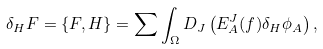Convert formula to latex. <formula><loc_0><loc_0><loc_500><loc_500>\delta _ { H } F = \{ F , H \} = \sum \int _ { \Omega } D _ { J } \left ( E ^ { J } _ { A } ( f ) \delta _ { H } \phi _ { A } \right ) ,</formula> 